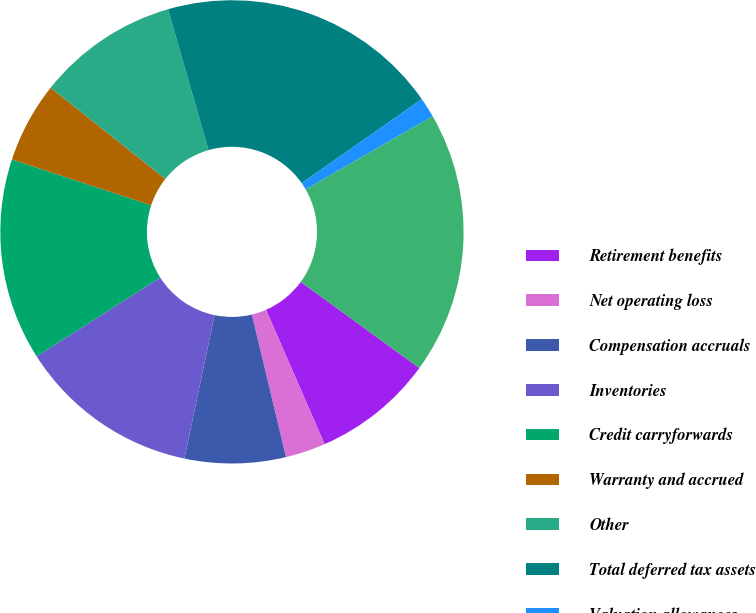Convert chart to OTSL. <chart><loc_0><loc_0><loc_500><loc_500><pie_chart><fcel>Retirement benefits<fcel>Net operating loss<fcel>Compensation accruals<fcel>Inventories<fcel>Credit carryforwards<fcel>Warranty and accrued<fcel>Other<fcel>Total deferred tax assets<fcel>Valuation allowances<fcel>Net deferred tax assets<nl><fcel>8.45%<fcel>2.8%<fcel>7.04%<fcel>12.68%<fcel>14.09%<fcel>5.63%<fcel>9.86%<fcel>19.74%<fcel>1.39%<fcel>18.32%<nl></chart> 